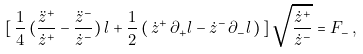Convert formula to latex. <formula><loc_0><loc_0><loc_500><loc_500>[ \, \frac { 1 } { 4 } \, ( \frac { \ddot { z } ^ { + } } { \dot { z } ^ { + } } - \frac { \ddot { z } ^ { - } } { \dot { z } ^ { - } } ) \, l + \frac { 1 } { 2 } \, ( \, \dot { z } ^ { + } \, \partial _ { + } l - \dot { z } ^ { - } \, \partial _ { - } l \, ) \, ] \, \sqrt { \frac { \dot { z } ^ { + } } { \dot { z } ^ { - } } } = F _ { - } \, ,</formula> 